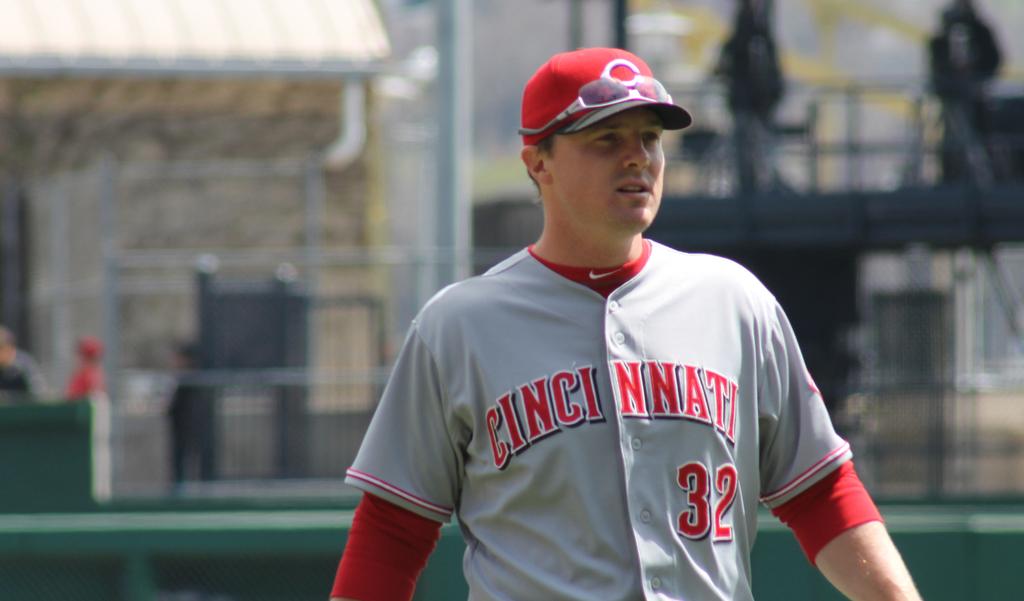What city does the baseball player represent?
Offer a terse response. Cincinnati. What is this players number?
Your answer should be compact. 32. 